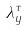<formula> <loc_0><loc_0><loc_500><loc_500>\lambda _ { y } ^ { \tau }</formula> 